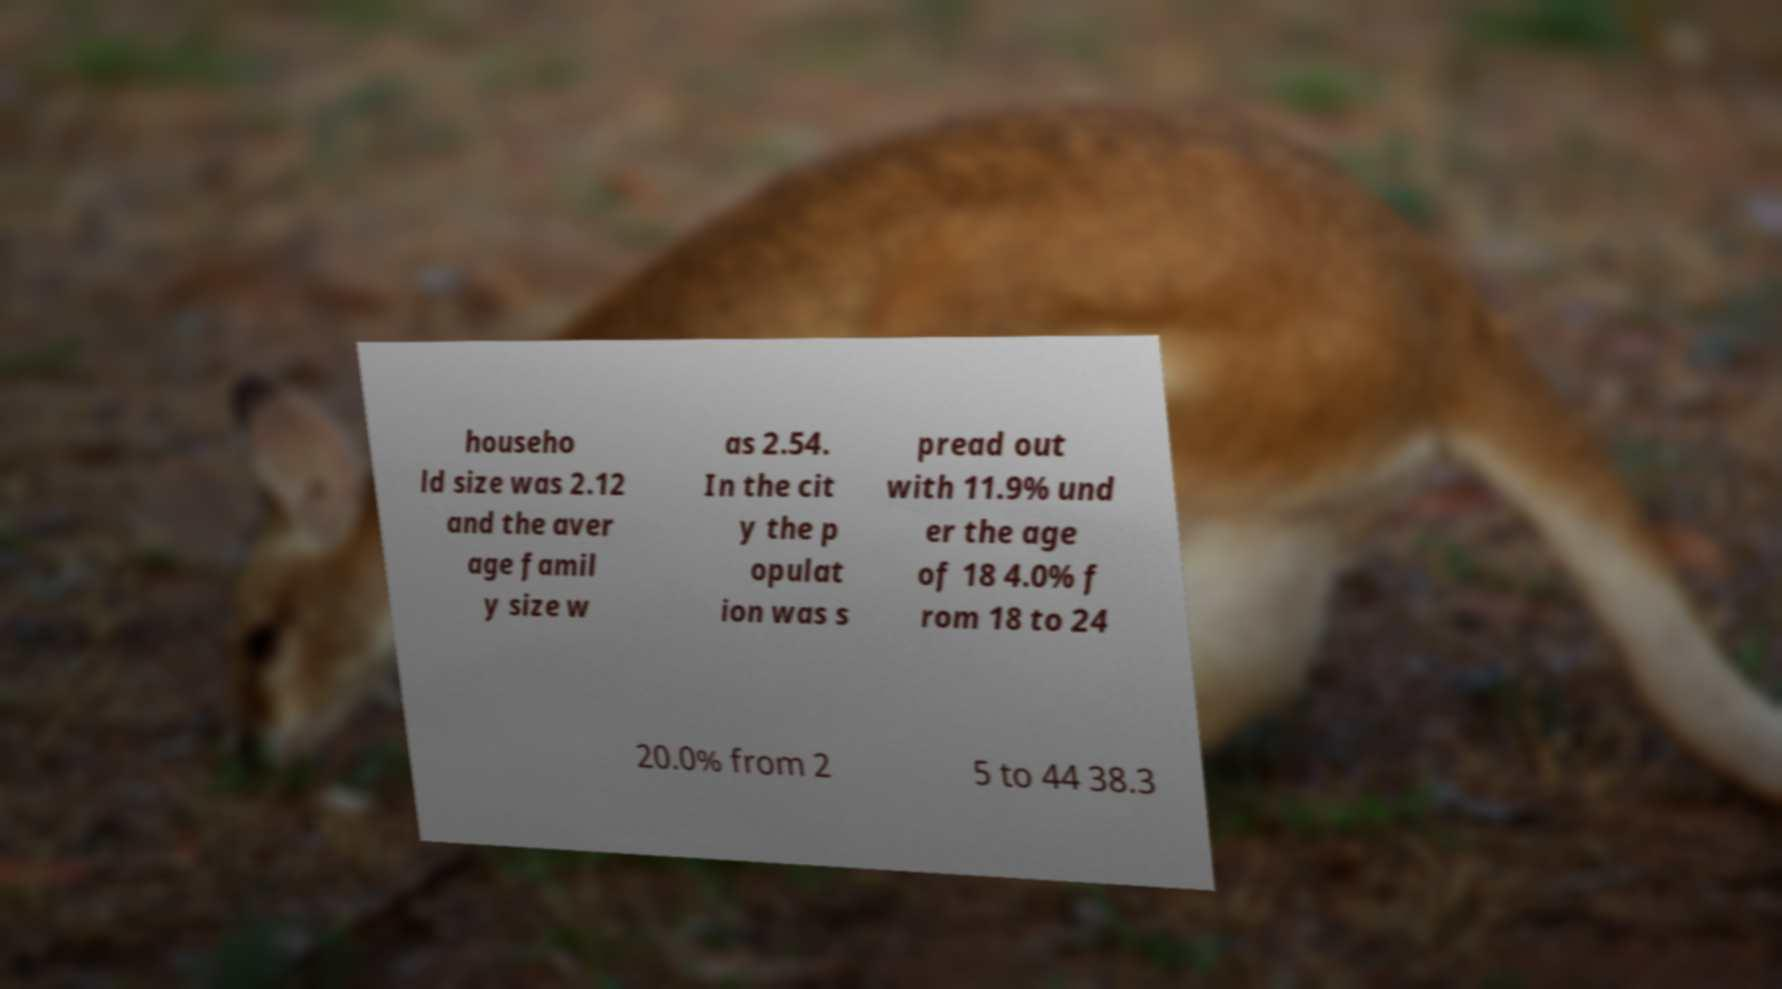I need the written content from this picture converted into text. Can you do that? househo ld size was 2.12 and the aver age famil y size w as 2.54. In the cit y the p opulat ion was s pread out with 11.9% und er the age of 18 4.0% f rom 18 to 24 20.0% from 2 5 to 44 38.3 